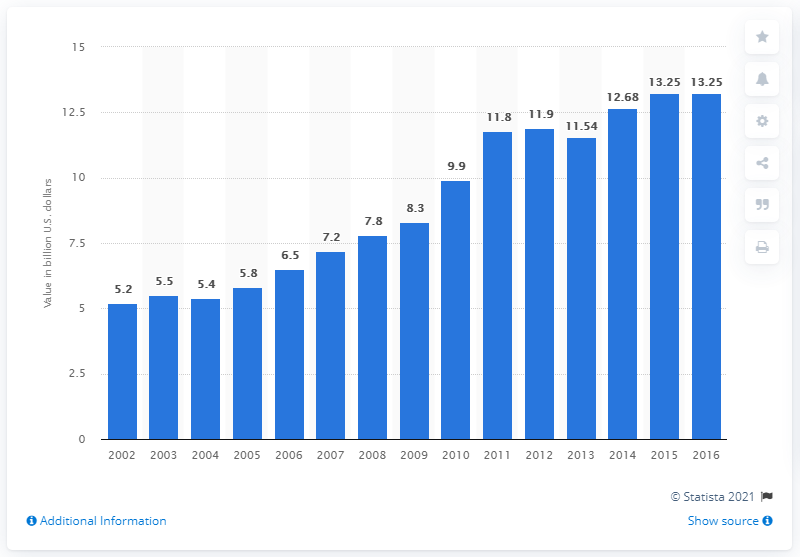Mention a couple of crucial points in this snapshot. The value of coffee and tea shipment in the United States in 2016 was 13.25. 